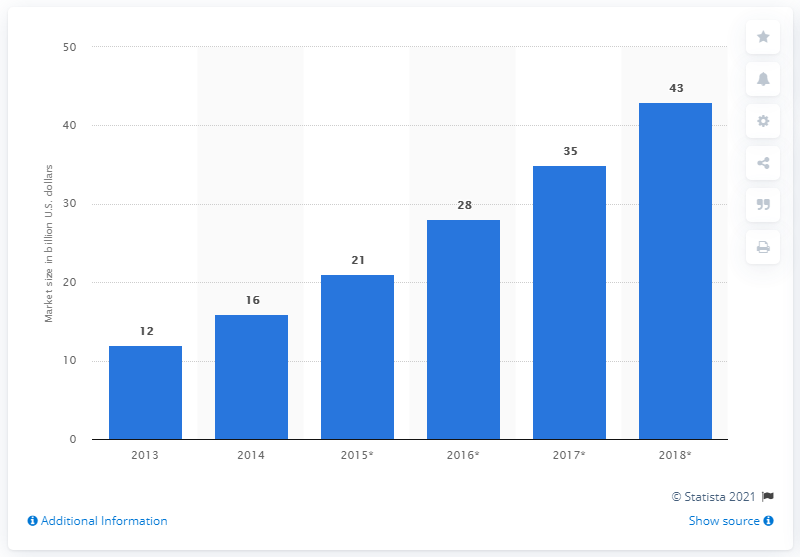List a handful of essential elements in this visual. According to projections, the cloud computing infrastructure and platform market is expected to reach a value of over 43 billion U.S. dollars by 2018. 